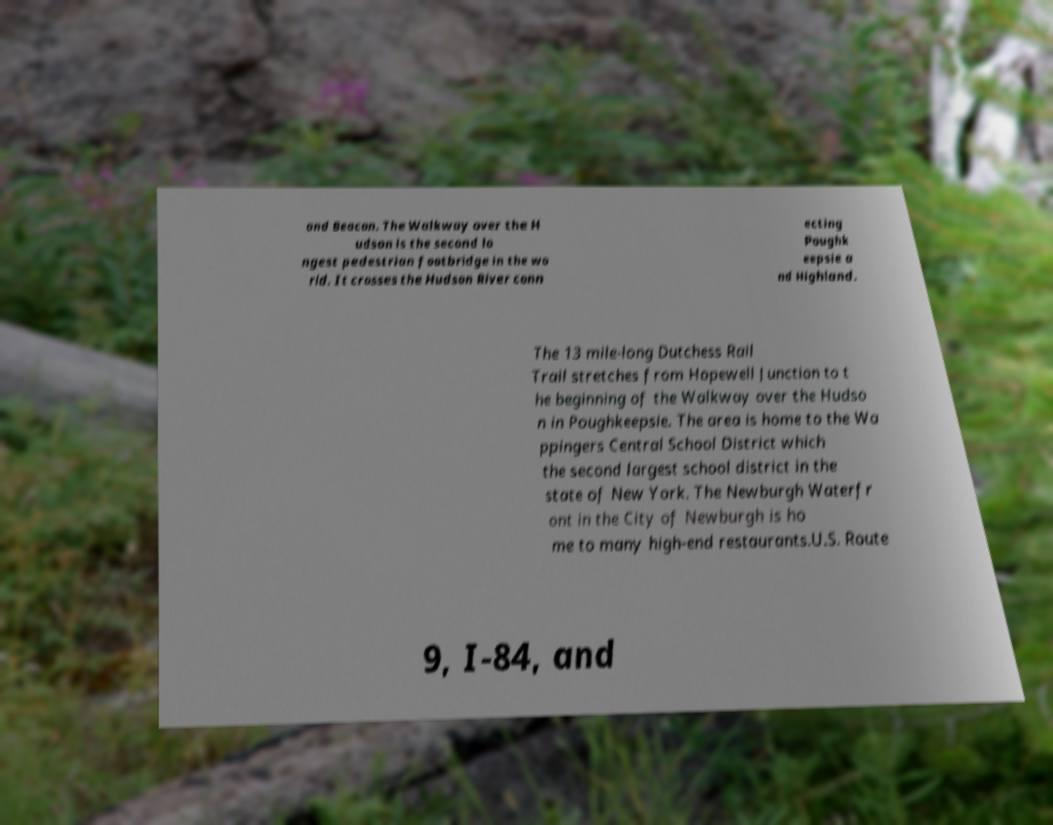For documentation purposes, I need the text within this image transcribed. Could you provide that? and Beacon. The Walkway over the H udson is the second lo ngest pedestrian footbridge in the wo rld. It crosses the Hudson River conn ecting Poughk eepsie a nd Highland. The 13 mile-long Dutchess Rail Trail stretches from Hopewell Junction to t he beginning of the Walkway over the Hudso n in Poughkeepsie. The area is home to the Wa ppingers Central School District which the second largest school district in the state of New York. The Newburgh Waterfr ont in the City of Newburgh is ho me to many high-end restaurants.U.S. Route 9, I-84, and 